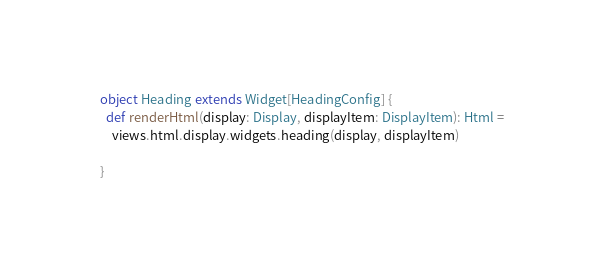<code> <loc_0><loc_0><loc_500><loc_500><_Scala_>object Heading extends Widget[HeadingConfig] {
  def renderHtml(display: Display, displayItem: DisplayItem): Html =
    views.html.display.widgets.heading(display, displayItem)

}
</code> 